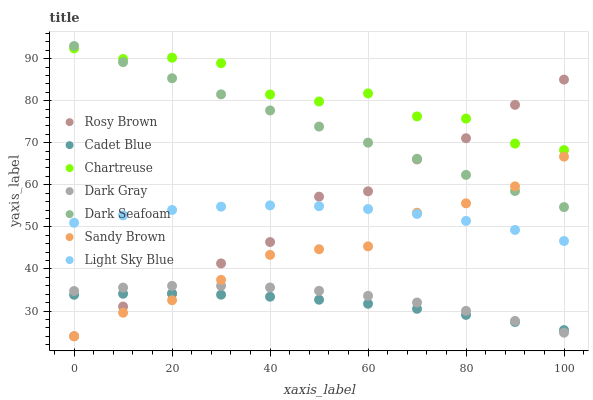Does Cadet Blue have the minimum area under the curve?
Answer yes or no. Yes. Does Chartreuse have the maximum area under the curve?
Answer yes or no. Yes. Does Rosy Brown have the minimum area under the curve?
Answer yes or no. No. Does Rosy Brown have the maximum area under the curve?
Answer yes or no. No. Is Dark Seafoam the smoothest?
Answer yes or no. Yes. Is Chartreuse the roughest?
Answer yes or no. Yes. Is Rosy Brown the smoothest?
Answer yes or no. No. Is Rosy Brown the roughest?
Answer yes or no. No. Does Rosy Brown have the lowest value?
Answer yes or no. Yes. Does Dark Seafoam have the lowest value?
Answer yes or no. No. Does Dark Seafoam have the highest value?
Answer yes or no. Yes. Does Rosy Brown have the highest value?
Answer yes or no. No. Is Dark Gray less than Chartreuse?
Answer yes or no. Yes. Is Chartreuse greater than Cadet Blue?
Answer yes or no. Yes. Does Light Sky Blue intersect Sandy Brown?
Answer yes or no. Yes. Is Light Sky Blue less than Sandy Brown?
Answer yes or no. No. Is Light Sky Blue greater than Sandy Brown?
Answer yes or no. No. Does Dark Gray intersect Chartreuse?
Answer yes or no. No. 